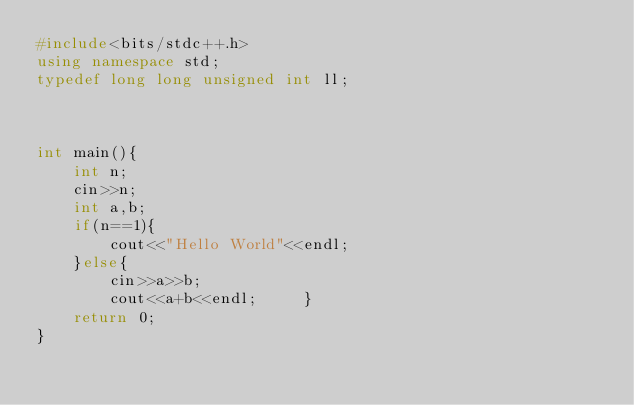<code> <loc_0><loc_0><loc_500><loc_500><_C++_>#include<bits/stdc++.h>
using namespace std;
typedef long long unsigned int ll;



int main(){
    int n;
    cin>>n;
    int a,b;
    if(n==1){
        cout<<"Hello World"<<endl;
    }else{
        cin>>a>>b;
        cout<<a+b<<endl;     }
    return 0;
}

</code> 